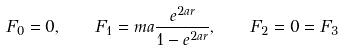Convert formula to latex. <formula><loc_0><loc_0><loc_500><loc_500>F _ { 0 } = 0 , \quad F _ { 1 } = m a \frac { e ^ { 2 a r } } { 1 - e ^ { 2 a r } } , \quad F _ { 2 } = 0 = F _ { 3 }</formula> 